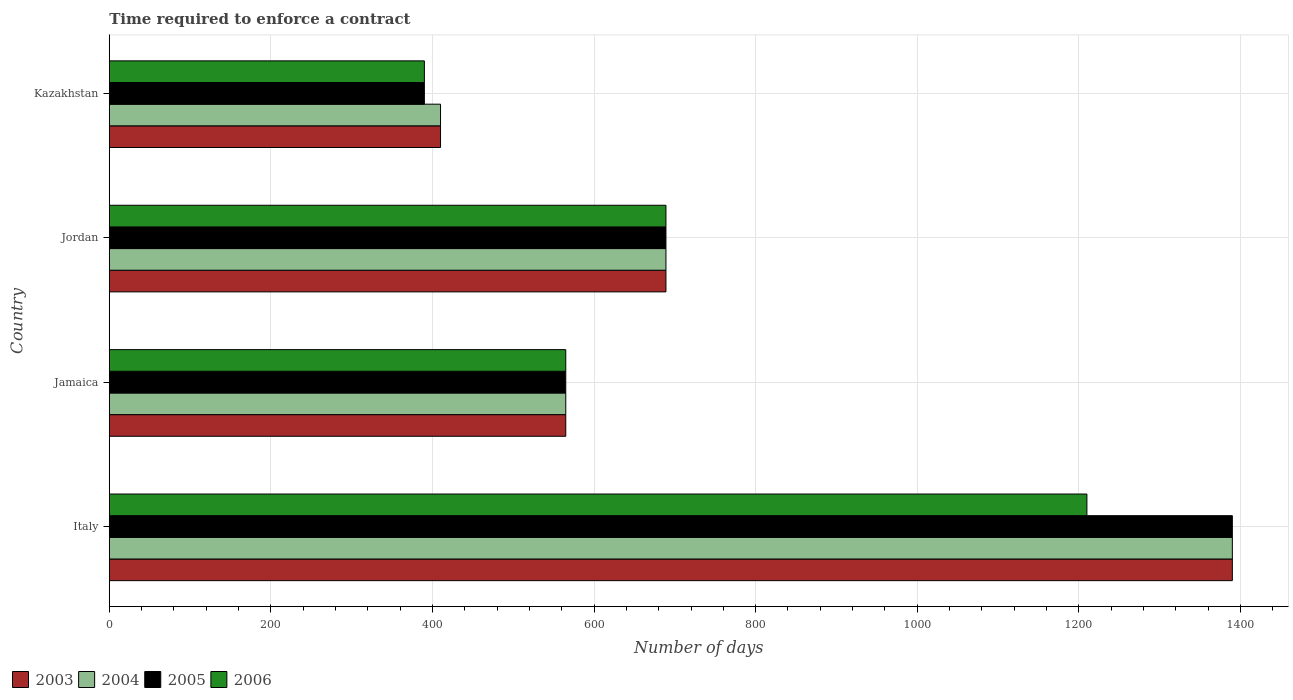How many groups of bars are there?
Provide a short and direct response. 4. Are the number of bars per tick equal to the number of legend labels?
Your response must be concise. Yes. What is the label of the 2nd group of bars from the top?
Give a very brief answer. Jordan. What is the number of days required to enforce a contract in 2006 in Jordan?
Ensure brevity in your answer.  689. Across all countries, what is the maximum number of days required to enforce a contract in 2003?
Provide a succinct answer. 1390. Across all countries, what is the minimum number of days required to enforce a contract in 2005?
Offer a very short reply. 390. In which country was the number of days required to enforce a contract in 2004 minimum?
Offer a very short reply. Kazakhstan. What is the total number of days required to enforce a contract in 2004 in the graph?
Offer a very short reply. 3054. What is the difference between the number of days required to enforce a contract in 2006 in Italy and that in Kazakhstan?
Your response must be concise. 820. What is the difference between the number of days required to enforce a contract in 2005 in Kazakhstan and the number of days required to enforce a contract in 2006 in Italy?
Give a very brief answer. -820. What is the average number of days required to enforce a contract in 2006 per country?
Provide a short and direct response. 713.5. What is the difference between the number of days required to enforce a contract in 2003 and number of days required to enforce a contract in 2004 in Jordan?
Offer a terse response. 0. What is the ratio of the number of days required to enforce a contract in 2003 in Italy to that in Jamaica?
Keep it short and to the point. 2.46. Is the number of days required to enforce a contract in 2005 in Italy less than that in Jordan?
Provide a short and direct response. No. What is the difference between the highest and the second highest number of days required to enforce a contract in 2003?
Keep it short and to the point. 701. What is the difference between the highest and the lowest number of days required to enforce a contract in 2005?
Your answer should be compact. 1000. Is it the case that in every country, the sum of the number of days required to enforce a contract in 2005 and number of days required to enforce a contract in 2004 is greater than the sum of number of days required to enforce a contract in 2003 and number of days required to enforce a contract in 2006?
Ensure brevity in your answer.  No. Is it the case that in every country, the sum of the number of days required to enforce a contract in 2006 and number of days required to enforce a contract in 2003 is greater than the number of days required to enforce a contract in 2004?
Make the answer very short. Yes. How many countries are there in the graph?
Offer a very short reply. 4. What is the difference between two consecutive major ticks on the X-axis?
Your response must be concise. 200. Are the values on the major ticks of X-axis written in scientific E-notation?
Make the answer very short. No. Where does the legend appear in the graph?
Offer a terse response. Bottom left. What is the title of the graph?
Offer a very short reply. Time required to enforce a contract. What is the label or title of the X-axis?
Provide a short and direct response. Number of days. What is the label or title of the Y-axis?
Keep it short and to the point. Country. What is the Number of days of 2003 in Italy?
Your answer should be compact. 1390. What is the Number of days in 2004 in Italy?
Ensure brevity in your answer.  1390. What is the Number of days of 2005 in Italy?
Offer a very short reply. 1390. What is the Number of days in 2006 in Italy?
Provide a short and direct response. 1210. What is the Number of days of 2003 in Jamaica?
Your answer should be compact. 565. What is the Number of days in 2004 in Jamaica?
Provide a succinct answer. 565. What is the Number of days of 2005 in Jamaica?
Your answer should be compact. 565. What is the Number of days of 2006 in Jamaica?
Offer a terse response. 565. What is the Number of days in 2003 in Jordan?
Offer a very short reply. 689. What is the Number of days of 2004 in Jordan?
Keep it short and to the point. 689. What is the Number of days in 2005 in Jordan?
Give a very brief answer. 689. What is the Number of days of 2006 in Jordan?
Make the answer very short. 689. What is the Number of days in 2003 in Kazakhstan?
Ensure brevity in your answer.  410. What is the Number of days of 2004 in Kazakhstan?
Give a very brief answer. 410. What is the Number of days in 2005 in Kazakhstan?
Ensure brevity in your answer.  390. What is the Number of days in 2006 in Kazakhstan?
Offer a terse response. 390. Across all countries, what is the maximum Number of days in 2003?
Your answer should be compact. 1390. Across all countries, what is the maximum Number of days of 2004?
Provide a succinct answer. 1390. Across all countries, what is the maximum Number of days of 2005?
Make the answer very short. 1390. Across all countries, what is the maximum Number of days of 2006?
Your answer should be very brief. 1210. Across all countries, what is the minimum Number of days in 2003?
Give a very brief answer. 410. Across all countries, what is the minimum Number of days in 2004?
Provide a succinct answer. 410. Across all countries, what is the minimum Number of days in 2005?
Provide a succinct answer. 390. Across all countries, what is the minimum Number of days in 2006?
Give a very brief answer. 390. What is the total Number of days in 2003 in the graph?
Provide a succinct answer. 3054. What is the total Number of days in 2004 in the graph?
Keep it short and to the point. 3054. What is the total Number of days of 2005 in the graph?
Provide a short and direct response. 3034. What is the total Number of days in 2006 in the graph?
Provide a short and direct response. 2854. What is the difference between the Number of days of 2003 in Italy and that in Jamaica?
Keep it short and to the point. 825. What is the difference between the Number of days in 2004 in Italy and that in Jamaica?
Offer a very short reply. 825. What is the difference between the Number of days of 2005 in Italy and that in Jamaica?
Offer a very short reply. 825. What is the difference between the Number of days of 2006 in Italy and that in Jamaica?
Give a very brief answer. 645. What is the difference between the Number of days of 2003 in Italy and that in Jordan?
Offer a terse response. 701. What is the difference between the Number of days of 2004 in Italy and that in Jordan?
Your answer should be very brief. 701. What is the difference between the Number of days in 2005 in Italy and that in Jordan?
Offer a terse response. 701. What is the difference between the Number of days in 2006 in Italy and that in Jordan?
Offer a terse response. 521. What is the difference between the Number of days of 2003 in Italy and that in Kazakhstan?
Make the answer very short. 980. What is the difference between the Number of days in 2004 in Italy and that in Kazakhstan?
Provide a succinct answer. 980. What is the difference between the Number of days of 2006 in Italy and that in Kazakhstan?
Your response must be concise. 820. What is the difference between the Number of days of 2003 in Jamaica and that in Jordan?
Give a very brief answer. -124. What is the difference between the Number of days of 2004 in Jamaica and that in Jordan?
Keep it short and to the point. -124. What is the difference between the Number of days of 2005 in Jamaica and that in Jordan?
Offer a terse response. -124. What is the difference between the Number of days in 2006 in Jamaica and that in Jordan?
Give a very brief answer. -124. What is the difference between the Number of days of 2003 in Jamaica and that in Kazakhstan?
Provide a short and direct response. 155. What is the difference between the Number of days in 2004 in Jamaica and that in Kazakhstan?
Your response must be concise. 155. What is the difference between the Number of days in 2005 in Jamaica and that in Kazakhstan?
Make the answer very short. 175. What is the difference between the Number of days of 2006 in Jamaica and that in Kazakhstan?
Give a very brief answer. 175. What is the difference between the Number of days of 2003 in Jordan and that in Kazakhstan?
Offer a very short reply. 279. What is the difference between the Number of days of 2004 in Jordan and that in Kazakhstan?
Your answer should be very brief. 279. What is the difference between the Number of days of 2005 in Jordan and that in Kazakhstan?
Your response must be concise. 299. What is the difference between the Number of days in 2006 in Jordan and that in Kazakhstan?
Provide a succinct answer. 299. What is the difference between the Number of days of 2003 in Italy and the Number of days of 2004 in Jamaica?
Keep it short and to the point. 825. What is the difference between the Number of days of 2003 in Italy and the Number of days of 2005 in Jamaica?
Your answer should be compact. 825. What is the difference between the Number of days of 2003 in Italy and the Number of days of 2006 in Jamaica?
Ensure brevity in your answer.  825. What is the difference between the Number of days of 2004 in Italy and the Number of days of 2005 in Jamaica?
Your answer should be very brief. 825. What is the difference between the Number of days in 2004 in Italy and the Number of days in 2006 in Jamaica?
Provide a short and direct response. 825. What is the difference between the Number of days of 2005 in Italy and the Number of days of 2006 in Jamaica?
Offer a very short reply. 825. What is the difference between the Number of days in 2003 in Italy and the Number of days in 2004 in Jordan?
Your answer should be compact. 701. What is the difference between the Number of days in 2003 in Italy and the Number of days in 2005 in Jordan?
Provide a succinct answer. 701. What is the difference between the Number of days of 2003 in Italy and the Number of days of 2006 in Jordan?
Make the answer very short. 701. What is the difference between the Number of days in 2004 in Italy and the Number of days in 2005 in Jordan?
Offer a very short reply. 701. What is the difference between the Number of days in 2004 in Italy and the Number of days in 2006 in Jordan?
Provide a succinct answer. 701. What is the difference between the Number of days of 2005 in Italy and the Number of days of 2006 in Jordan?
Offer a terse response. 701. What is the difference between the Number of days of 2003 in Italy and the Number of days of 2004 in Kazakhstan?
Provide a short and direct response. 980. What is the difference between the Number of days of 2003 in Italy and the Number of days of 2005 in Kazakhstan?
Provide a succinct answer. 1000. What is the difference between the Number of days in 2004 in Italy and the Number of days in 2005 in Kazakhstan?
Ensure brevity in your answer.  1000. What is the difference between the Number of days in 2004 in Italy and the Number of days in 2006 in Kazakhstan?
Make the answer very short. 1000. What is the difference between the Number of days of 2003 in Jamaica and the Number of days of 2004 in Jordan?
Provide a short and direct response. -124. What is the difference between the Number of days in 2003 in Jamaica and the Number of days in 2005 in Jordan?
Offer a very short reply. -124. What is the difference between the Number of days in 2003 in Jamaica and the Number of days in 2006 in Jordan?
Your response must be concise. -124. What is the difference between the Number of days in 2004 in Jamaica and the Number of days in 2005 in Jordan?
Keep it short and to the point. -124. What is the difference between the Number of days of 2004 in Jamaica and the Number of days of 2006 in Jordan?
Give a very brief answer. -124. What is the difference between the Number of days in 2005 in Jamaica and the Number of days in 2006 in Jordan?
Offer a terse response. -124. What is the difference between the Number of days in 2003 in Jamaica and the Number of days in 2004 in Kazakhstan?
Provide a succinct answer. 155. What is the difference between the Number of days of 2003 in Jamaica and the Number of days of 2005 in Kazakhstan?
Provide a succinct answer. 175. What is the difference between the Number of days in 2003 in Jamaica and the Number of days in 2006 in Kazakhstan?
Your answer should be very brief. 175. What is the difference between the Number of days in 2004 in Jamaica and the Number of days in 2005 in Kazakhstan?
Provide a succinct answer. 175. What is the difference between the Number of days of 2004 in Jamaica and the Number of days of 2006 in Kazakhstan?
Your response must be concise. 175. What is the difference between the Number of days of 2005 in Jamaica and the Number of days of 2006 in Kazakhstan?
Your answer should be very brief. 175. What is the difference between the Number of days of 2003 in Jordan and the Number of days of 2004 in Kazakhstan?
Your answer should be very brief. 279. What is the difference between the Number of days of 2003 in Jordan and the Number of days of 2005 in Kazakhstan?
Your response must be concise. 299. What is the difference between the Number of days of 2003 in Jordan and the Number of days of 2006 in Kazakhstan?
Your answer should be very brief. 299. What is the difference between the Number of days in 2004 in Jordan and the Number of days in 2005 in Kazakhstan?
Provide a succinct answer. 299. What is the difference between the Number of days in 2004 in Jordan and the Number of days in 2006 in Kazakhstan?
Your answer should be compact. 299. What is the difference between the Number of days of 2005 in Jordan and the Number of days of 2006 in Kazakhstan?
Provide a short and direct response. 299. What is the average Number of days of 2003 per country?
Your response must be concise. 763.5. What is the average Number of days in 2004 per country?
Your response must be concise. 763.5. What is the average Number of days in 2005 per country?
Your answer should be very brief. 758.5. What is the average Number of days in 2006 per country?
Give a very brief answer. 713.5. What is the difference between the Number of days in 2003 and Number of days in 2006 in Italy?
Give a very brief answer. 180. What is the difference between the Number of days of 2004 and Number of days of 2005 in Italy?
Your response must be concise. 0. What is the difference between the Number of days of 2004 and Number of days of 2006 in Italy?
Provide a short and direct response. 180. What is the difference between the Number of days in 2005 and Number of days in 2006 in Italy?
Keep it short and to the point. 180. What is the difference between the Number of days in 2004 and Number of days in 2005 in Jamaica?
Provide a succinct answer. 0. What is the difference between the Number of days in 2005 and Number of days in 2006 in Jamaica?
Give a very brief answer. 0. What is the difference between the Number of days in 2003 and Number of days in 2004 in Jordan?
Your response must be concise. 0. What is the difference between the Number of days of 2003 and Number of days of 2005 in Jordan?
Offer a very short reply. 0. What is the difference between the Number of days of 2003 and Number of days of 2006 in Jordan?
Your answer should be very brief. 0. What is the difference between the Number of days of 2004 and Number of days of 2006 in Jordan?
Give a very brief answer. 0. What is the difference between the Number of days in 2003 and Number of days in 2004 in Kazakhstan?
Offer a very short reply. 0. What is the difference between the Number of days of 2003 and Number of days of 2005 in Kazakhstan?
Your answer should be compact. 20. What is the difference between the Number of days in 2003 and Number of days in 2006 in Kazakhstan?
Offer a terse response. 20. What is the difference between the Number of days of 2004 and Number of days of 2005 in Kazakhstan?
Ensure brevity in your answer.  20. What is the difference between the Number of days in 2005 and Number of days in 2006 in Kazakhstan?
Give a very brief answer. 0. What is the ratio of the Number of days in 2003 in Italy to that in Jamaica?
Make the answer very short. 2.46. What is the ratio of the Number of days in 2004 in Italy to that in Jamaica?
Make the answer very short. 2.46. What is the ratio of the Number of days of 2005 in Italy to that in Jamaica?
Provide a succinct answer. 2.46. What is the ratio of the Number of days of 2006 in Italy to that in Jamaica?
Your answer should be very brief. 2.14. What is the ratio of the Number of days in 2003 in Italy to that in Jordan?
Your answer should be compact. 2.02. What is the ratio of the Number of days of 2004 in Italy to that in Jordan?
Provide a short and direct response. 2.02. What is the ratio of the Number of days of 2005 in Italy to that in Jordan?
Offer a very short reply. 2.02. What is the ratio of the Number of days of 2006 in Italy to that in Jordan?
Offer a terse response. 1.76. What is the ratio of the Number of days in 2003 in Italy to that in Kazakhstan?
Provide a succinct answer. 3.39. What is the ratio of the Number of days of 2004 in Italy to that in Kazakhstan?
Keep it short and to the point. 3.39. What is the ratio of the Number of days of 2005 in Italy to that in Kazakhstan?
Make the answer very short. 3.56. What is the ratio of the Number of days in 2006 in Italy to that in Kazakhstan?
Provide a short and direct response. 3.1. What is the ratio of the Number of days of 2003 in Jamaica to that in Jordan?
Your answer should be very brief. 0.82. What is the ratio of the Number of days of 2004 in Jamaica to that in Jordan?
Offer a very short reply. 0.82. What is the ratio of the Number of days of 2005 in Jamaica to that in Jordan?
Offer a very short reply. 0.82. What is the ratio of the Number of days of 2006 in Jamaica to that in Jordan?
Provide a short and direct response. 0.82. What is the ratio of the Number of days of 2003 in Jamaica to that in Kazakhstan?
Give a very brief answer. 1.38. What is the ratio of the Number of days of 2004 in Jamaica to that in Kazakhstan?
Keep it short and to the point. 1.38. What is the ratio of the Number of days of 2005 in Jamaica to that in Kazakhstan?
Offer a terse response. 1.45. What is the ratio of the Number of days in 2006 in Jamaica to that in Kazakhstan?
Give a very brief answer. 1.45. What is the ratio of the Number of days of 2003 in Jordan to that in Kazakhstan?
Keep it short and to the point. 1.68. What is the ratio of the Number of days in 2004 in Jordan to that in Kazakhstan?
Make the answer very short. 1.68. What is the ratio of the Number of days of 2005 in Jordan to that in Kazakhstan?
Provide a short and direct response. 1.77. What is the ratio of the Number of days of 2006 in Jordan to that in Kazakhstan?
Ensure brevity in your answer.  1.77. What is the difference between the highest and the second highest Number of days of 2003?
Your answer should be very brief. 701. What is the difference between the highest and the second highest Number of days of 2004?
Your response must be concise. 701. What is the difference between the highest and the second highest Number of days in 2005?
Ensure brevity in your answer.  701. What is the difference between the highest and the second highest Number of days in 2006?
Your response must be concise. 521. What is the difference between the highest and the lowest Number of days in 2003?
Ensure brevity in your answer.  980. What is the difference between the highest and the lowest Number of days of 2004?
Give a very brief answer. 980. What is the difference between the highest and the lowest Number of days of 2005?
Make the answer very short. 1000. What is the difference between the highest and the lowest Number of days in 2006?
Offer a terse response. 820. 